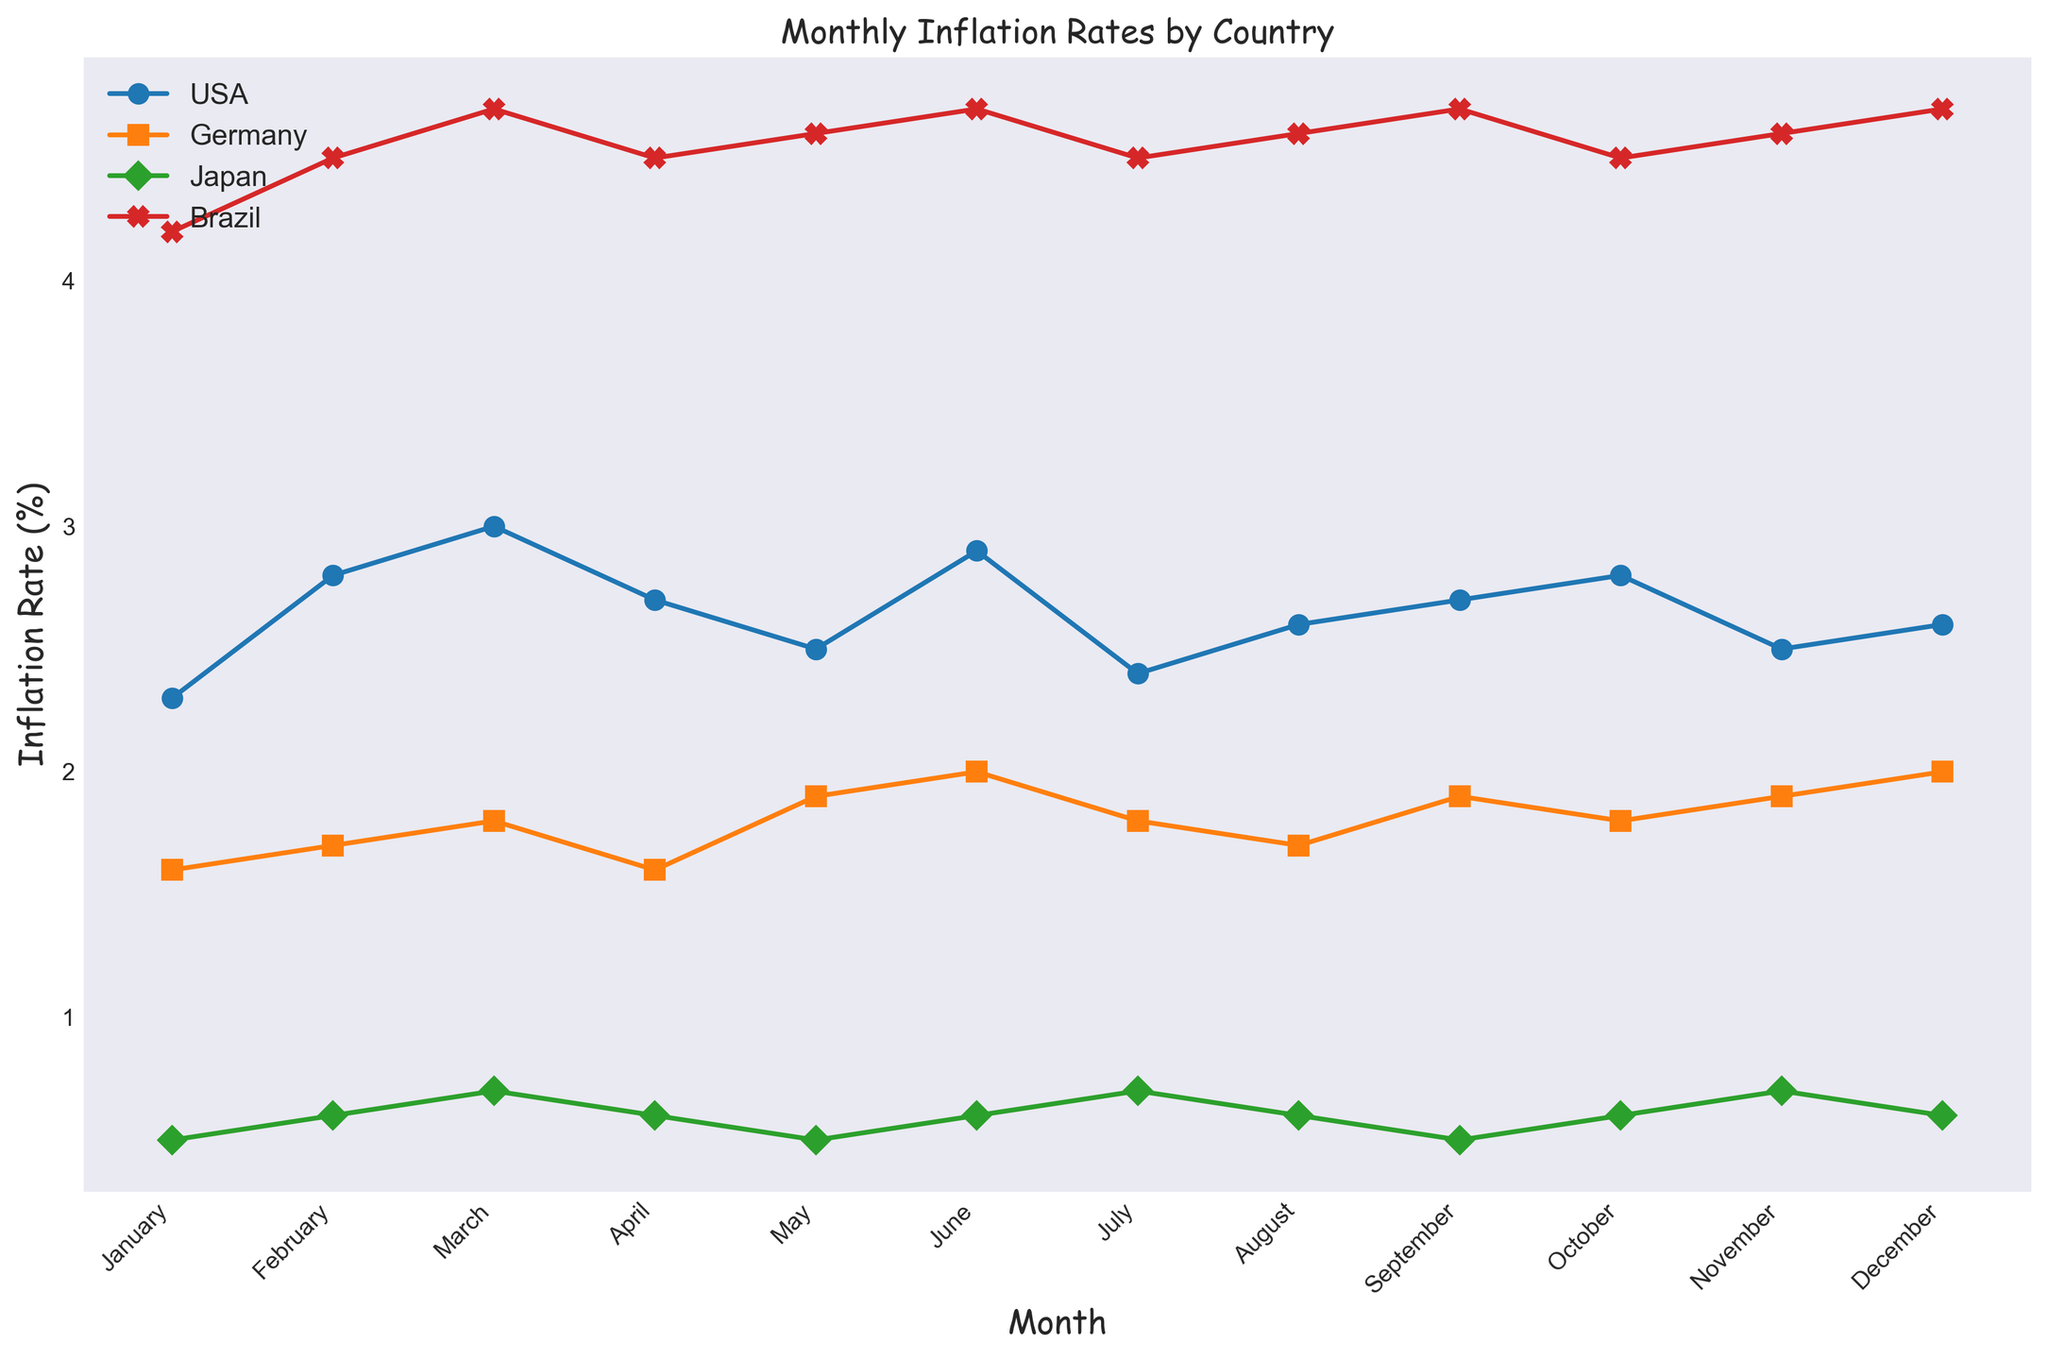Which country had the highest inflation rate in December? To answer this question, observe the last data point for each country. The highest inflation rate in December is 4.7%, which belongs to Brazil.
Answer: Brazil Between Germany and Japan, which country had a more stable inflation rate throughout the year? To assess stability, look at the fluctuation in the lines representing each country. Japan's line is relatively flat, indicating more stability, while Germany's line shows more variation.
Answer: Japan What is the average inflation rate in the USA over the whole year? Sum the monthly inflation rates for the USA and divide by 12. The total is 2.8 + 2.3 + 2.8 + 3.0 + 2.7 + 2.5 + 2.6 + 2.9 + 2.4 + 2.7 + 2.8 + 2.5 + 2.6 = 31.8. The average is 31.8 / 12 = 2.65%.
Answer: 2.65% How does the inflation rate in March compare between all four countries? Check the data points for March. The inflation rates are: USA - 3.0%, Germany - 1.8%, Japan - 0.7%, Brazil - 4.7%.
Answer: USA: 3.0%, Germany: 1.8%, Japan: 0.7%, Brazil: 4.7% Which month shows the highest inflation for Germany? Examine Germany's line, the peak inflation rate is in June and December with 2.0%.
Answer: June and December In which month did Brazil experience its lowest inflation rate, and what was the rate? Scan Brazil's line for the lowest point. All values are either 4.5% or higher, but the lowest rate occurs in January, April, July, and October at 4.5%.
Answer: January, April, July, October, 4.5% Which countries had at least one month where the inflation rate was higher than 3%? Compare all data points to 3%. Only the USA and Brazil had months with rates above 3%.
Answer: USA, Brazil Which color represents Japan's inflation rate in the plot? Referring to the plot legend, the color associated with Japan's line is green.
Answer: Green Calculate the difference between the highest and lowest inflation rates observed for the USA. The highest rate is 3.0% in March, and the lowest rate is 2.3% in January. The difference is 3.0% - 2.3% = 0.7%.
Answer: 0.7% In November, which country had the second-highest inflation rate? Check the inflation rates for November: USA - 2.5%, Germany - 1.9%, Japan - 0.7%, Brazil - 4.6%. The second-highest is the USA with 2.5%.
Answer: USA 